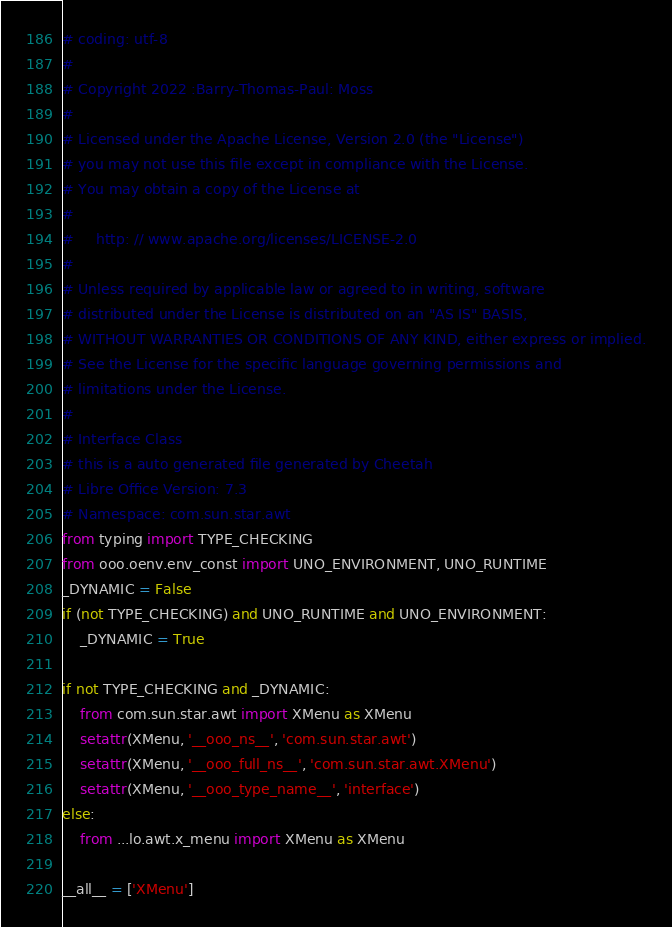<code> <loc_0><loc_0><loc_500><loc_500><_Python_># coding: utf-8
#
# Copyright 2022 :Barry-Thomas-Paul: Moss
#
# Licensed under the Apache License, Version 2.0 (the "License")
# you may not use this file except in compliance with the License.
# You may obtain a copy of the License at
#
#     http: // www.apache.org/licenses/LICENSE-2.0
#
# Unless required by applicable law or agreed to in writing, software
# distributed under the License is distributed on an "AS IS" BASIS,
# WITHOUT WARRANTIES OR CONDITIONS OF ANY KIND, either express or implied.
# See the License for the specific language governing permissions and
# limitations under the License.
#
# Interface Class
# this is a auto generated file generated by Cheetah
# Libre Office Version: 7.3
# Namespace: com.sun.star.awt
from typing import TYPE_CHECKING
from ooo.oenv.env_const import UNO_ENVIRONMENT, UNO_RUNTIME
_DYNAMIC = False
if (not TYPE_CHECKING) and UNO_RUNTIME and UNO_ENVIRONMENT:
    _DYNAMIC = True

if not TYPE_CHECKING and _DYNAMIC:
    from com.sun.star.awt import XMenu as XMenu
    setattr(XMenu, '__ooo_ns__', 'com.sun.star.awt')
    setattr(XMenu, '__ooo_full_ns__', 'com.sun.star.awt.XMenu')
    setattr(XMenu, '__ooo_type_name__', 'interface')
else:
    from ...lo.awt.x_menu import XMenu as XMenu

__all__ = ['XMenu']

</code> 